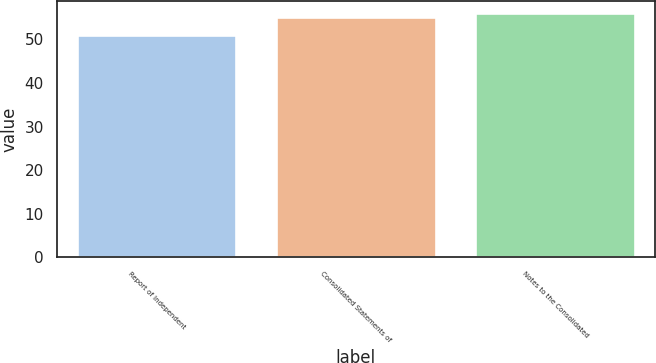Convert chart to OTSL. <chart><loc_0><loc_0><loc_500><loc_500><bar_chart><fcel>Report of Independent<fcel>Consolidated Statements of<fcel>Notes to the Consolidated<nl><fcel>51<fcel>55<fcel>56<nl></chart> 